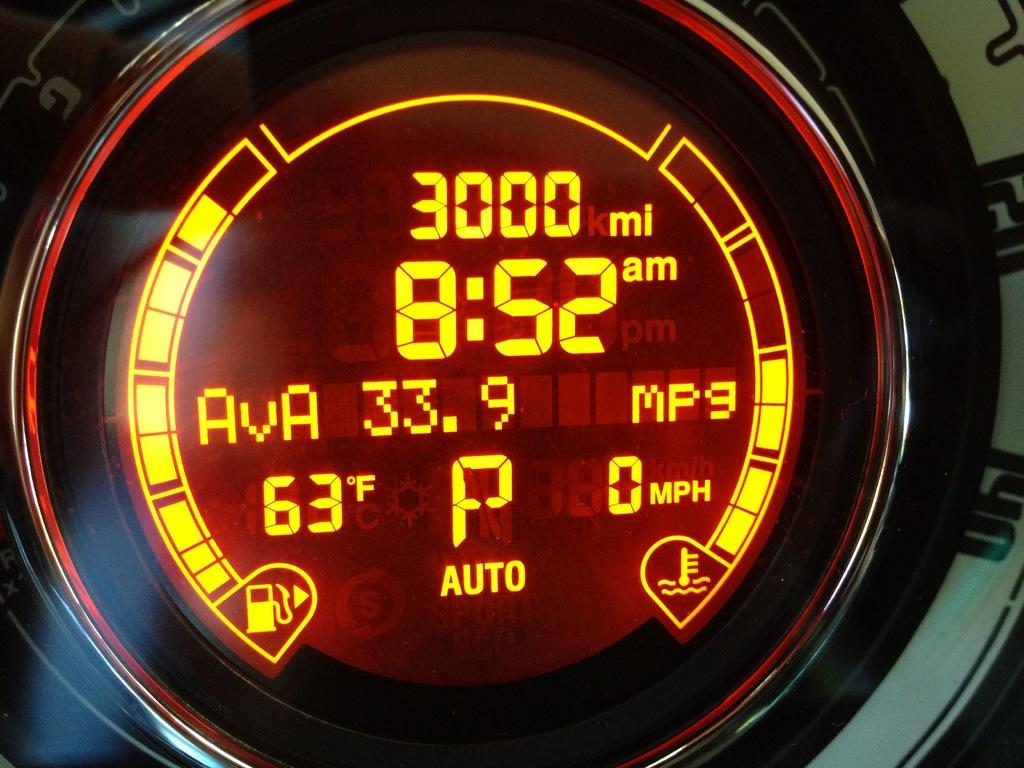<image>
Render a clear and concise summary of the photo. a dial on  a car dash that says '3000 mi and 8:52' on it 